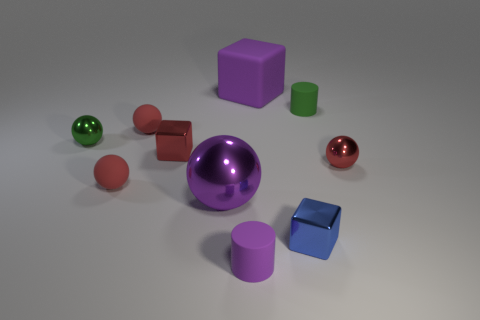Subtract all red spheres. How many were subtracted if there are1red spheres left? 2 Subtract all small red matte spheres. How many spheres are left? 3 Subtract all purple cubes. How many cubes are left? 2 Subtract all red cubes. How many red spheres are left? 3 Subtract all cubes. How many objects are left? 7 Subtract 1 cylinders. How many cylinders are left? 1 Subtract all blue shiny cubes. Subtract all red metal cubes. How many objects are left? 8 Add 1 small red metallic spheres. How many small red metallic spheres are left? 2 Add 9 tiny purple cylinders. How many tiny purple cylinders exist? 10 Subtract 0 yellow cylinders. How many objects are left? 10 